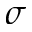<formula> <loc_0><loc_0><loc_500><loc_500>\sigma</formula> 